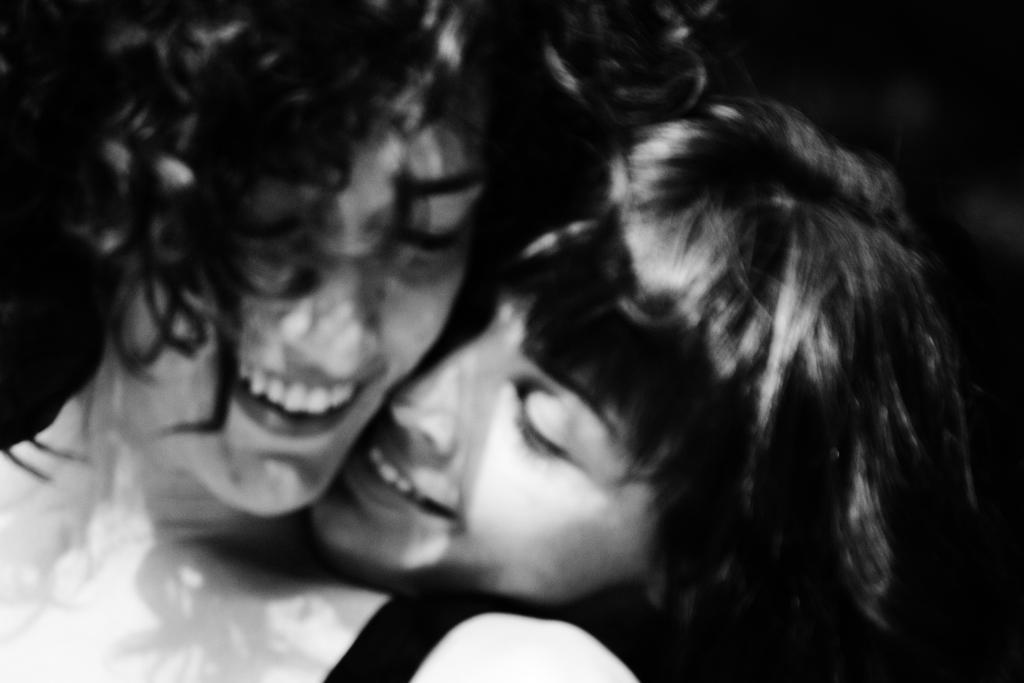Describe this image in one or two sentences. In this image we can see two people and the background is dark. 